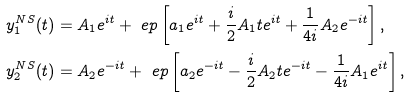<formula> <loc_0><loc_0><loc_500><loc_500>y _ { 1 } ^ { N S } ( t ) & = A _ { 1 } e ^ { i t } + \ e p \left [ a _ { 1 } e ^ { i t } + \frac { i } { 2 } A _ { 1 } t e ^ { i t } + \frac { 1 } { 4 i } A _ { 2 } e ^ { - i t } \right ] , \\ y _ { 2 } ^ { N S } ( t ) & = A _ { 2 } e ^ { - i t } + \ e p \left [ a _ { 2 } e ^ { - i t } - \frac { i } { 2 } A _ { 2 } t e ^ { - i t } - \frac { 1 } { 4 i } A _ { 1 } e ^ { i t } \right ] , \\</formula> 